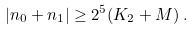<formula> <loc_0><loc_0><loc_500><loc_500>| n _ { 0 } + n _ { 1 } | \geq 2 ^ { 5 } ( K _ { 2 } + M ) \, .</formula> 